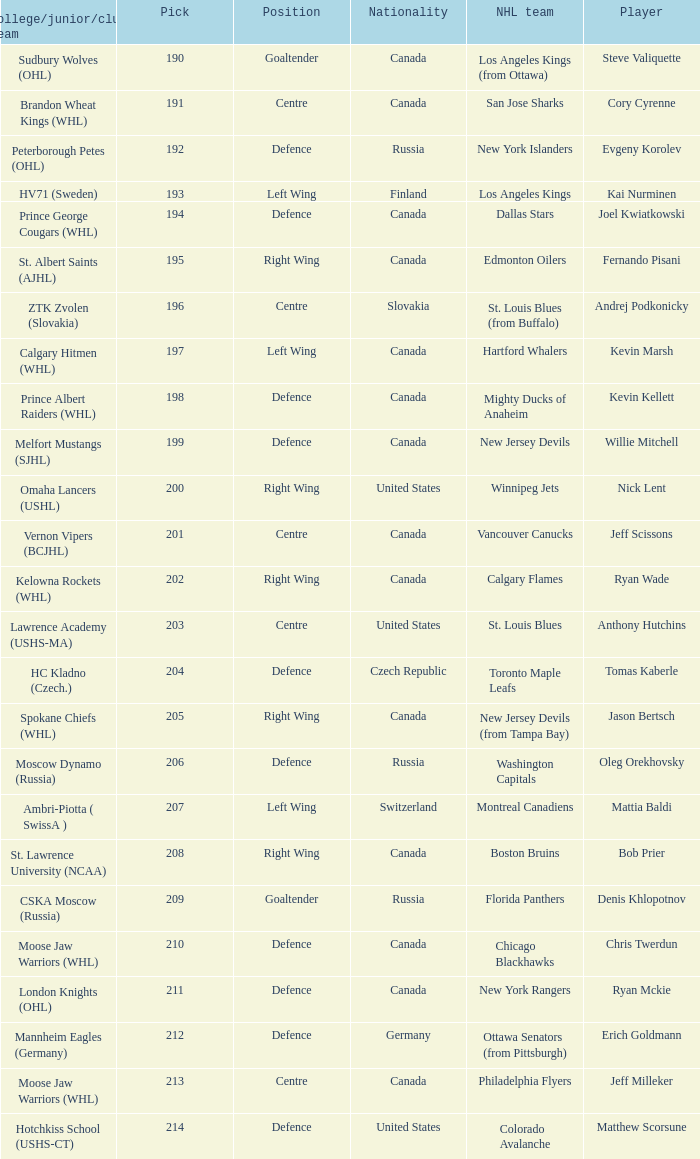Name the college for andrej podkonicky ZTK Zvolen (Slovakia). 